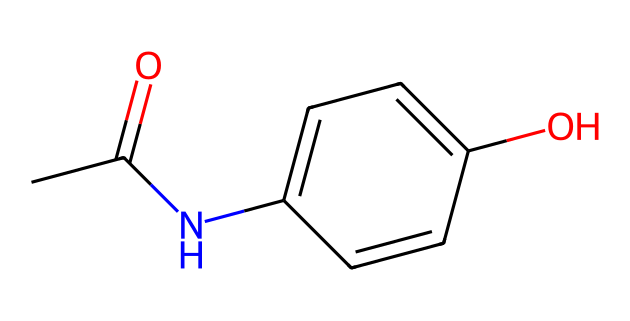What is the molecular formula of acetaminophen? To determine the molecular formula, we analyze the SMILES representation. The structure contains 8 carbon atoms, 9 hydrogen atoms, 1 nitrogen atom, and 2 oxygen atoms. This leads us to the molecular formula C8H9NO2.
Answer: C8H9NO2 How many rings are present in the structure? By examining the SMILES, there is one distinct ring in the structure, indicated by the "C1" which starts and ends the cyclic portion of the molecule.
Answer: 1 What functional groups are present in acetaminophen? The SMILES representation shows an acetyl group (indicated by CC(=O)) and a hydroxyl group (indicated by the -OH in the aromatic system), thus both functional groups are present.
Answer: acetyl and hydroxyl groups What is the significance of the nitrogen atom in this compound? The nitrogen atom implies the presence of amide functionality, which is critical for the drug's mechanism of action as it enhances pain-relieving properties through interaction with biological receptors.
Answer: amide functionality How many total bonds are present in acetaminophen? By focusing on the connectivity within the SMILES, we identify the types of bonds including carbon-carbon, carbon-hydrogen, carbon-nitrogen, and carbon-oxygen bonds. Adding these up gives a total of 13 bonds.
Answer: 13 What type of drug is acetaminophen classified as? Given the structure and its pain-relieving properties, acetaminophen is classified as an analgesic and antipyretic agent, functioning primarily to relieve pain and reduce fever.
Answer: analgesic and antipyretic 